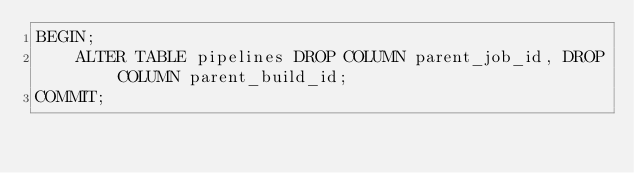Convert code to text. <code><loc_0><loc_0><loc_500><loc_500><_SQL_>BEGIN;
    ALTER TABLE pipelines DROP COLUMN parent_job_id, DROP COLUMN parent_build_id;
COMMIT;
</code> 